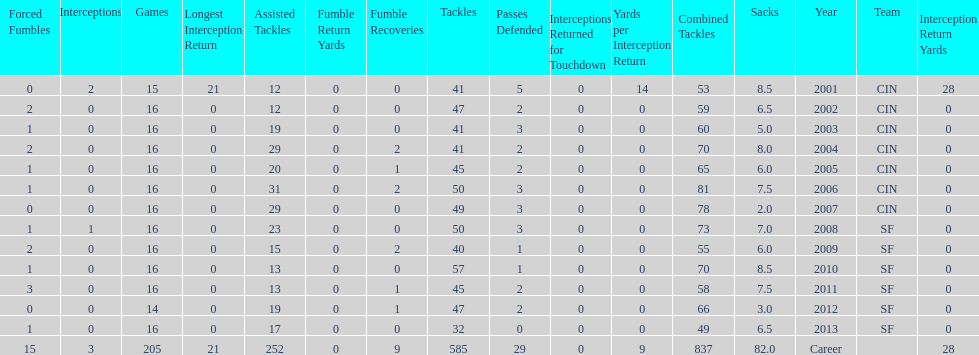What is the only season he has fewer than three sacks? 2007. 